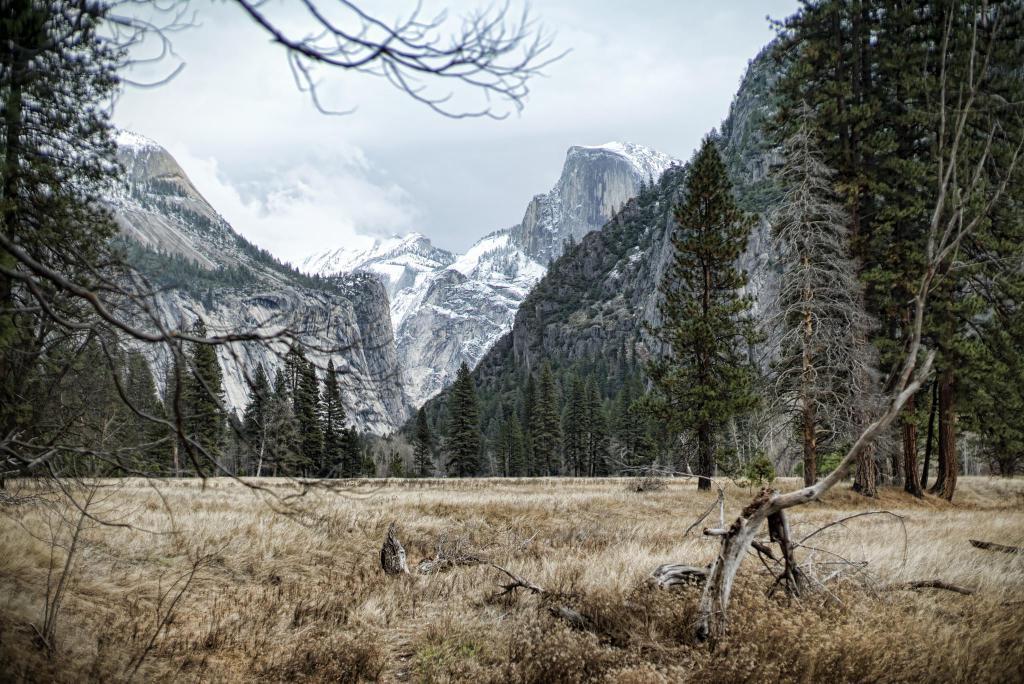Describe this image in one or two sentences. The image is taken in a forest. In the foreground of the picture there are shrubs, grass, wooden logs, trees, branches and other objects. In the center of the picture there are trees and mountains covered with snow and trees. In the background it is sky. 